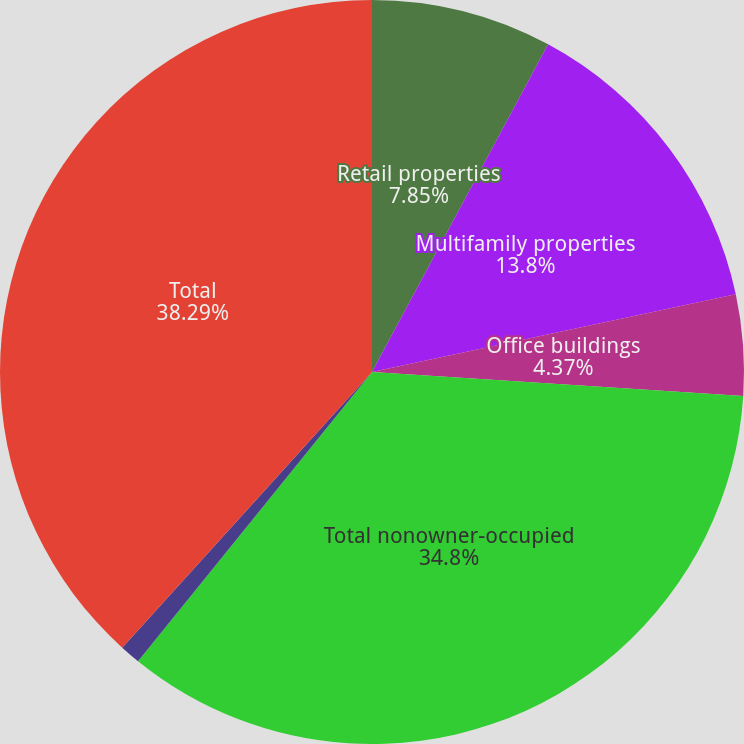Convert chart to OTSL. <chart><loc_0><loc_0><loc_500><loc_500><pie_chart><fcel>Retail properties<fcel>Multifamily properties<fcel>Office buildings<fcel>Total nonowner-occupied<fcel>Owner-occupied<fcel>Total<nl><fcel>7.85%<fcel>13.8%<fcel>4.37%<fcel>34.8%<fcel>0.89%<fcel>38.28%<nl></chart> 